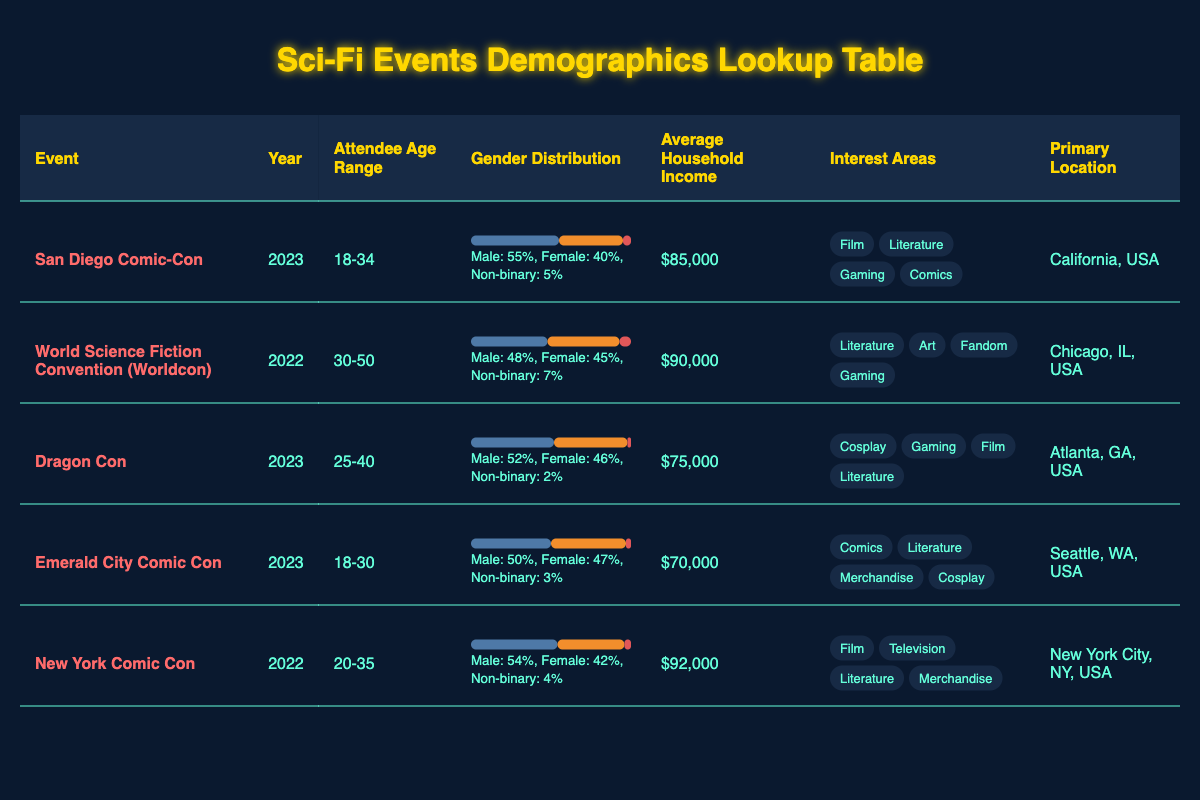What is the primary location of the San Diego Comic-Con? By checking the row corresponding to San Diego Comic-Con, we see that the primary location listed is California, USA.
Answer: California, USA Which event had the highest average household income? Looking at the average household income values for each event, New York Comic Con has the highest income at $92,000 compared to other events listed.
Answer: $92,000 Are there more male or female attendees at Dragon Con? In the gender distribution for Dragon Con, males represent 52% while females are 46%, indicating more male attendees.
Answer: Yes, more males What is the age range of attendees for the World Science Fiction Convention? By examining the row for the World Science Fiction Convention, we find that the attendee age range is 30-50 years.
Answer: 30-50 What is the difference in average household income between the San Diego Comic-Con and the Emerald City Comic Con? The average household income for San Diego Comic-Con is $85,000 and for Emerald City Comic Con is $70,000. The difference is $85,000 - $70,000 = $15,000.
Answer: $15,000 Which event had the least percentage of non-binary attendees? Evaluating the non-binary percentages from the gender distributions, Dragon Con shows the least at 2%, which is lower than all other events.
Answer: Dragon Con How many interest areas are listed for the New York Comic Con? Referring to the New York Comic Con row, there are four interest areas mentioned: Film, Television, Literature, and Merchandise.
Answer: 4 What percentage of attendees at the Emerald City Comic Con identify as female? From the gender distribution section for Emerald City Comic Con, it is noted that 47% of attendees identify as female.
Answer: 47% Which event had the most balanced gender distribution based on the percentages provided? By analyzing the gender distribution percentages, the World Science Fiction Convention has male at 48%, female at 45%, and non-binary at 7%. This indicates a balanced representation compared to others with larger disparities.
Answer: World Science Fiction Convention 